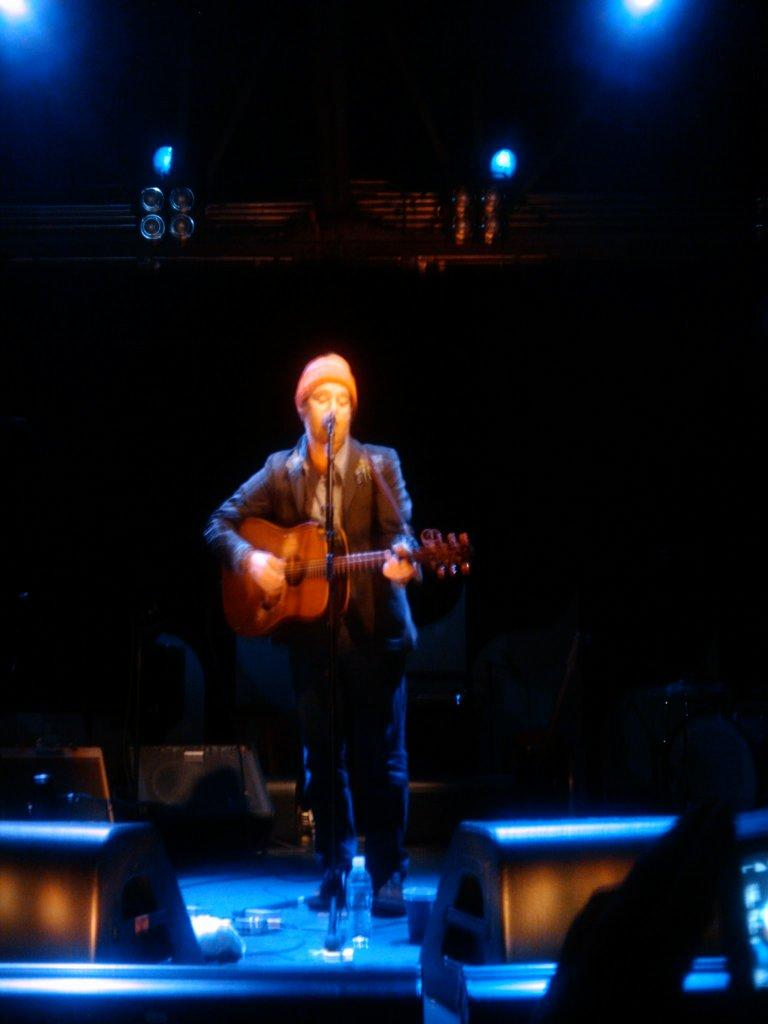Who is the person in the image? There is a man in the image. What is the man wearing? The man is wearing a blazer and jeans. What is the man doing in the image? The man is standing and holding a guitar. What object is in front of the man? There is a microphone in front of the man. What can be seen in the background of the image? There are lights visible in the background, and the sky is dark. What type of sign can be seen in the image? There is no sign present in the image. 